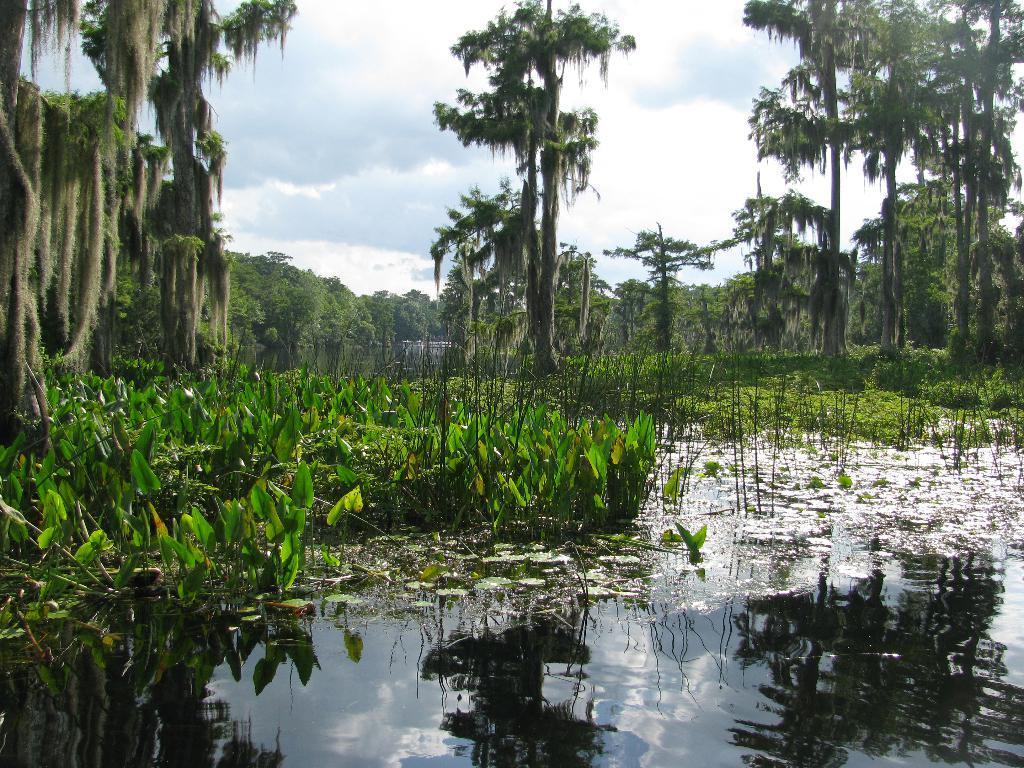How would you summarize this image in a sentence or two? This image is taken outdoors. At the top of the image there is the sky with clouds. In the background there are many trees and plants with leaves, stems and branches. At the bottom of the image there is a pond with water. There are many duck weeds in the pond. 